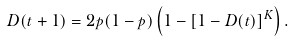<formula> <loc_0><loc_0><loc_500><loc_500>D ( t + 1 ) = 2 p ( 1 - p ) \left ( 1 - [ 1 - D ( t ) ] ^ { K } \right ) .</formula> 